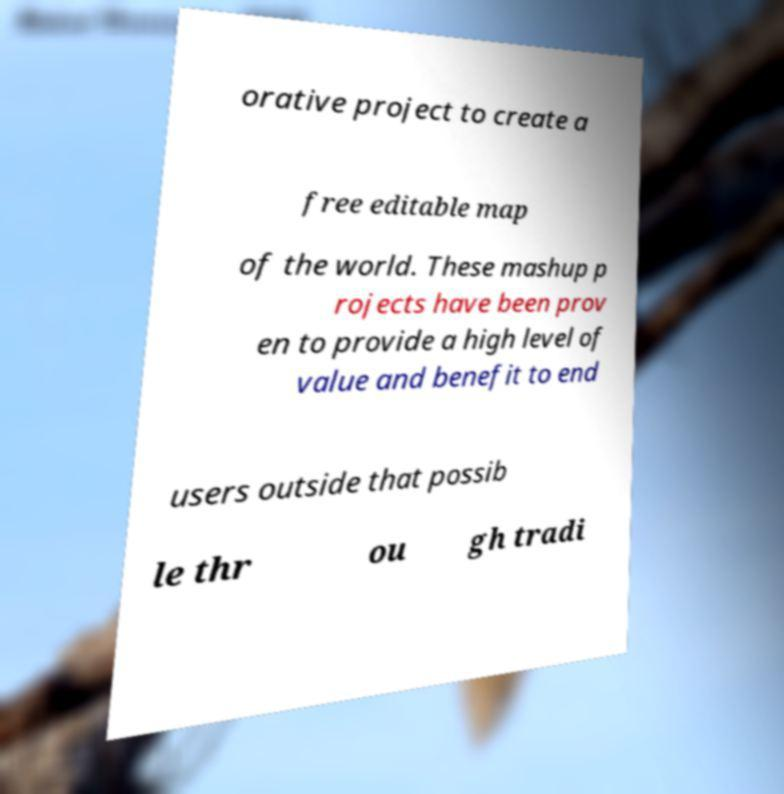Could you extract and type out the text from this image? orative project to create a free editable map of the world. These mashup p rojects have been prov en to provide a high level of value and benefit to end users outside that possib le thr ou gh tradi 